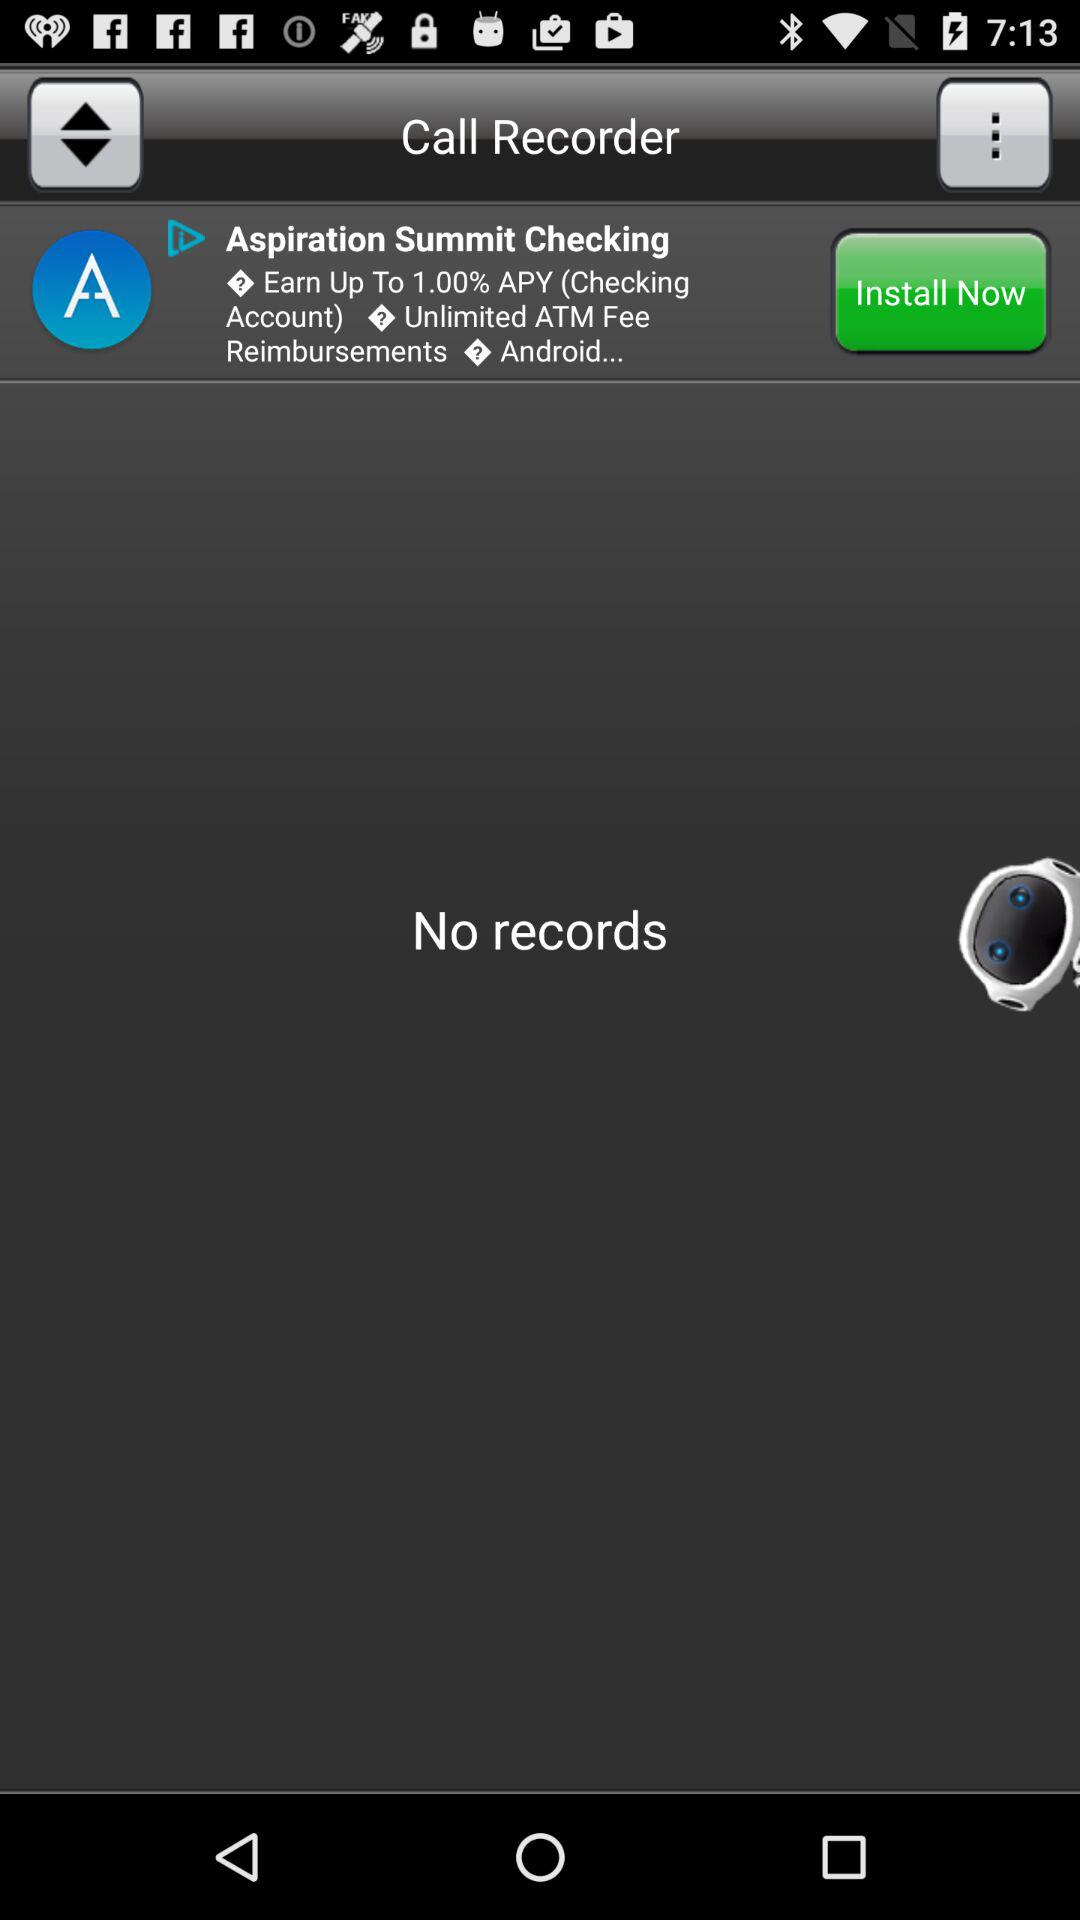Are there any records? There are no records. 